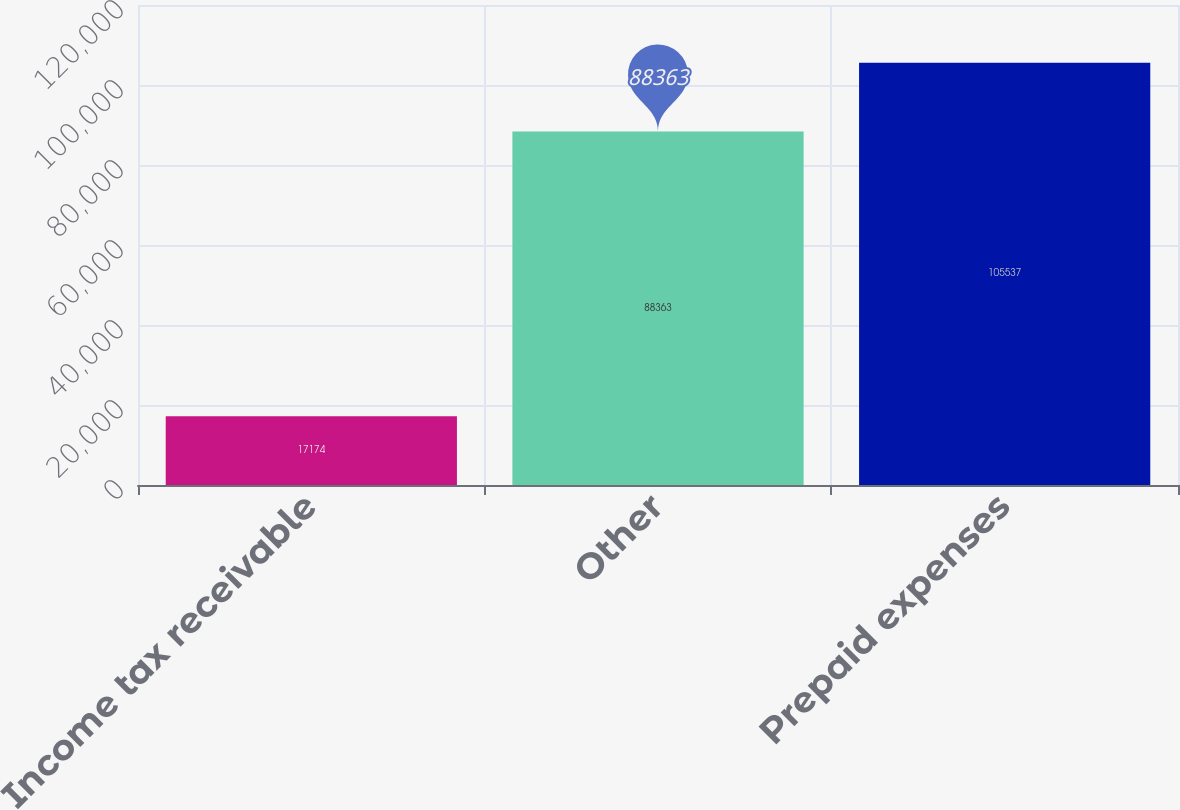Convert chart to OTSL. <chart><loc_0><loc_0><loc_500><loc_500><bar_chart><fcel>Income tax receivable<fcel>Other<fcel>Prepaid expenses<nl><fcel>17174<fcel>88363<fcel>105537<nl></chart> 